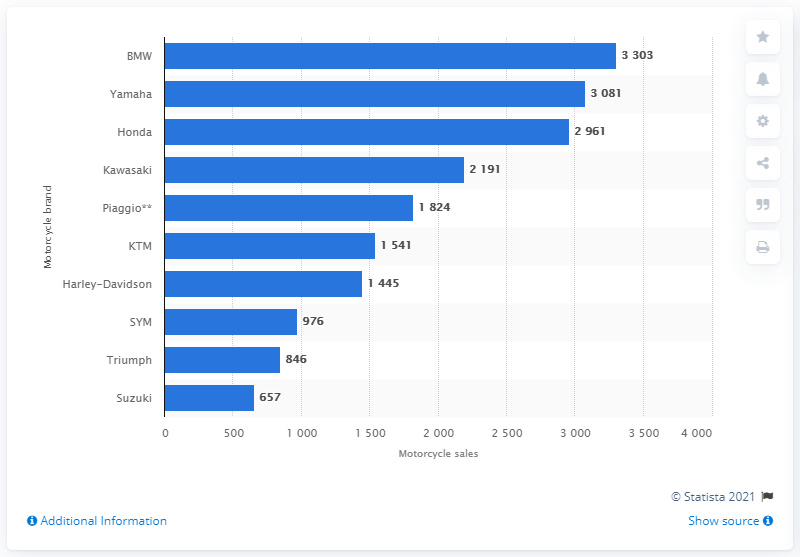Point out several critical features in this image. In 2019, BMW was the brand that sold the most motorbikes in Belgium. 